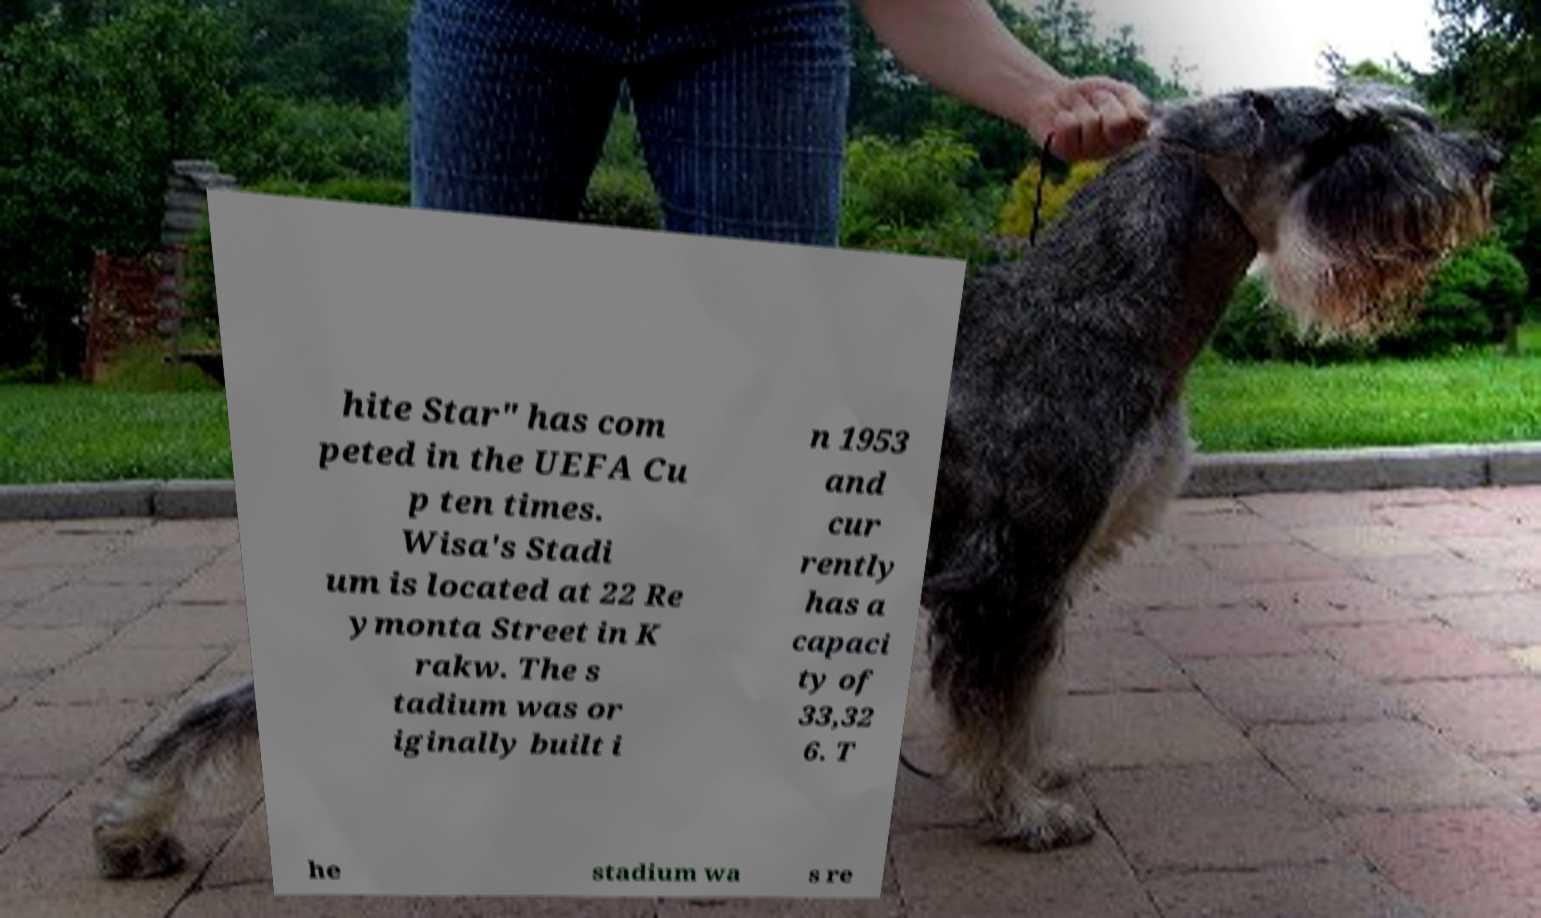Please identify and transcribe the text found in this image. hite Star" has com peted in the UEFA Cu p ten times. Wisa's Stadi um is located at 22 Re ymonta Street in K rakw. The s tadium was or iginally built i n 1953 and cur rently has a capaci ty of 33,32 6. T he stadium wa s re 